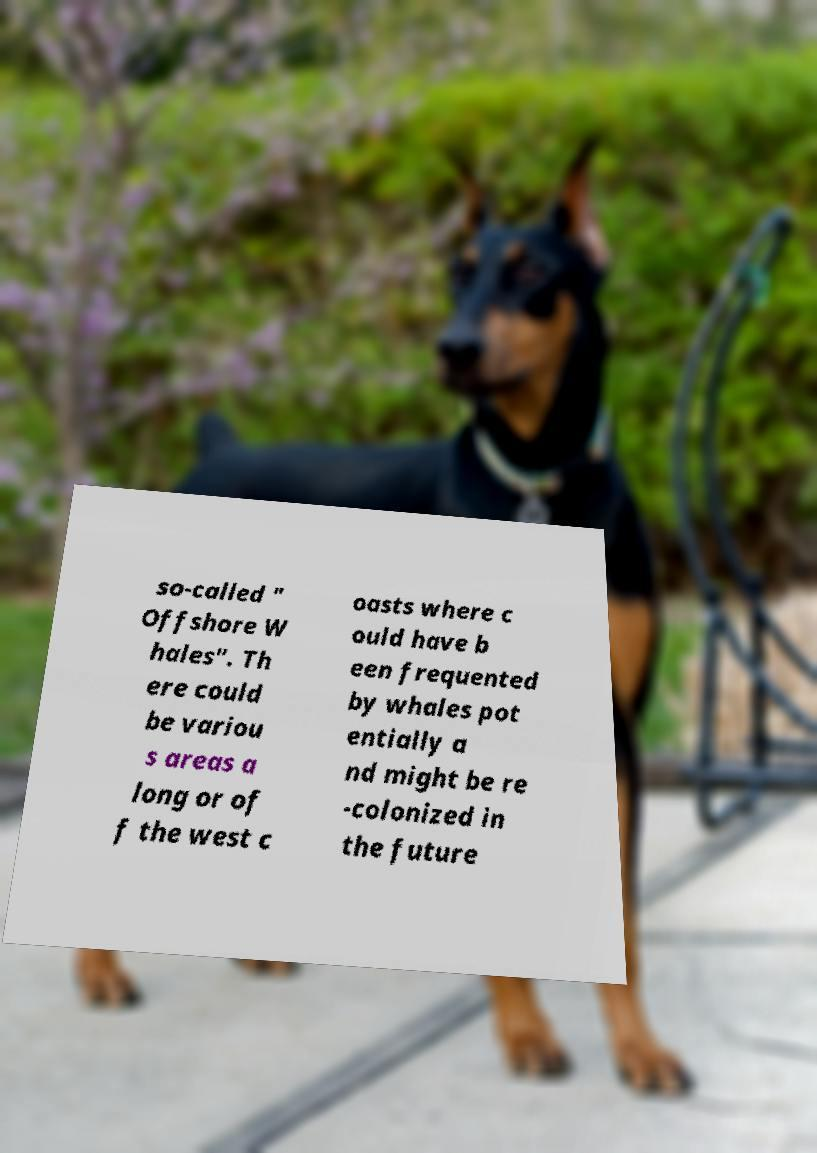For documentation purposes, I need the text within this image transcribed. Could you provide that? so-called " Offshore W hales". Th ere could be variou s areas a long or of f the west c oasts where c ould have b een frequented by whales pot entially a nd might be re -colonized in the future 